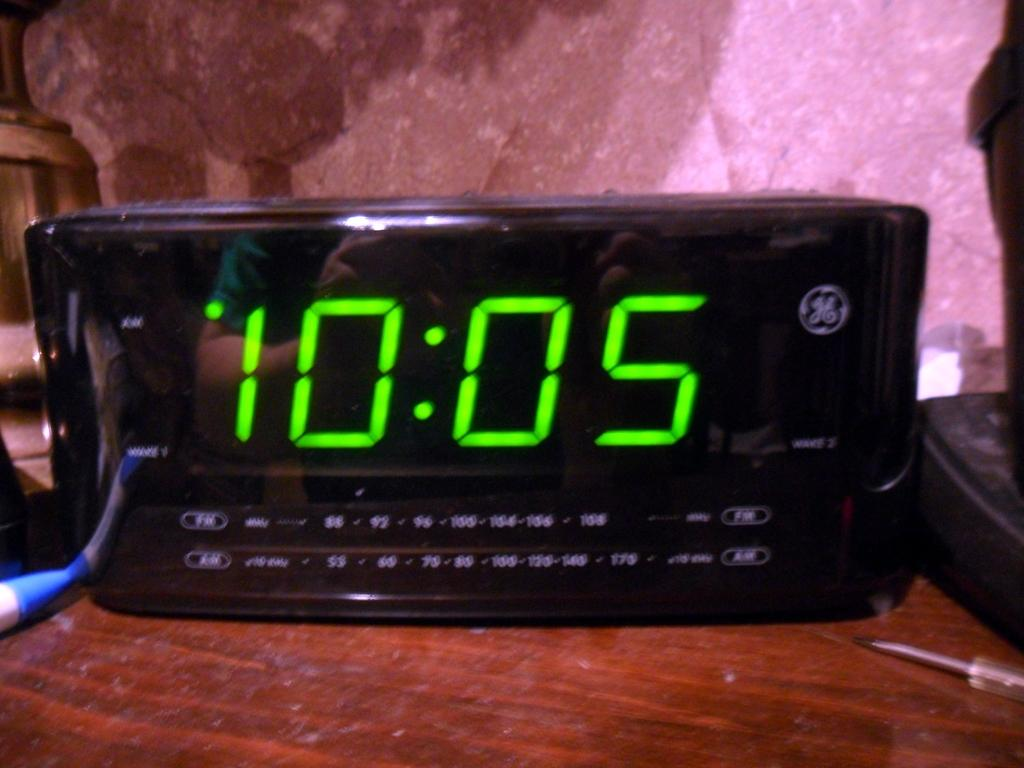<image>
Write a terse but informative summary of the picture. An alarm clock made by GE displays the time of 10:05. 